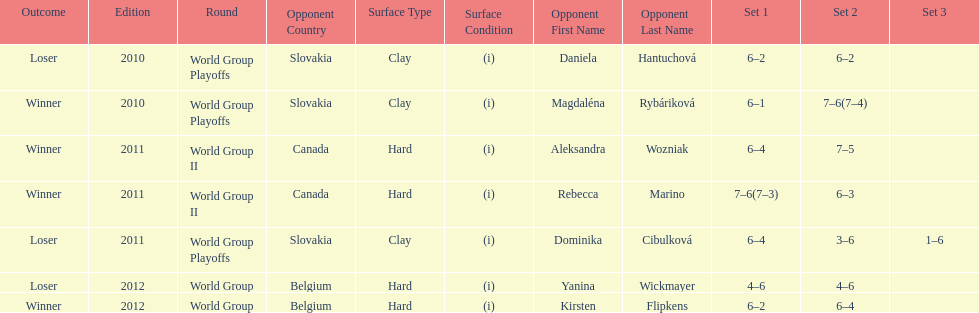Did they beat canada in more or less than 3 matches? Less. 